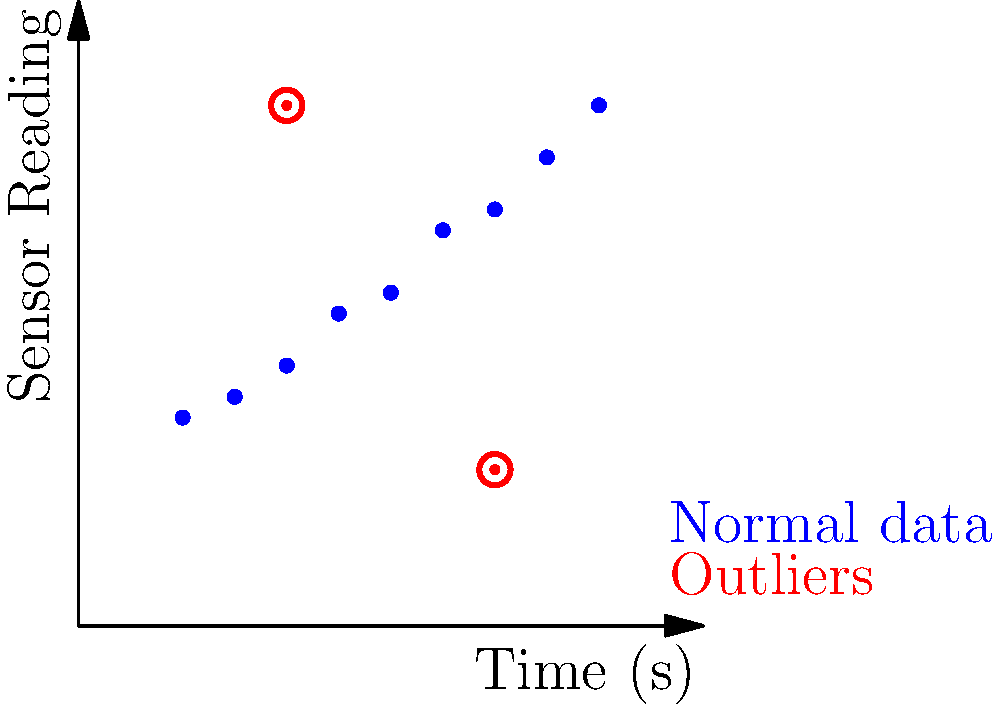In the scatter plot above, sensor readings from an Android device are plotted against time. Which anomaly detection technique would be most appropriate for identifying the red points as outliers, considering the linear trend in the normal data? To determine the most appropriate anomaly detection technique, let's analyze the scatter plot step-by-step:

1. Data distribution: The blue points show a clear linear trend, increasing over time.

2. Outliers: The red points deviate significantly from this linear trend.

3. Characteristics of the anomalies:
   a. They are individual points, not clusters.
   b. They deviate in the y-axis (sensor reading) direction.

4. Considering these factors, we need a technique that can:
   a. Account for the linear trend in the data.
   b. Identify individual points as outliers.
   c. Be sensitive to deviations in the y-axis direction.

5. Potential techniques:
   a. Simple threshold-based methods would not work due to the increasing trend.
   b. Clustering-based methods like DBSCAN might not be ideal for individual outliers.
   c. Statistical methods like Z-score would struggle with the non-stationary nature of the data.

6. The most appropriate technique would be Regression-based Anomaly Detection:
   a. It can model the linear trend in the data.
   b. It can identify individual points that deviate significantly from the expected values.
   c. It's sensitive to y-axis deviations, which is where our outliers are most prominent.

7. Implementation would involve:
   a. Fitting a linear regression line to the normal data.
   b. Calculating the residuals (differences between actual and predicted values).
   c. Setting a threshold for residuals to classify points as outliers.

This method aligns well with the cautious nature of an Android developer, as it provides a systematic and interpretable approach to anomaly detection in time-series sensor data.
Answer: Regression-based Anomaly Detection 